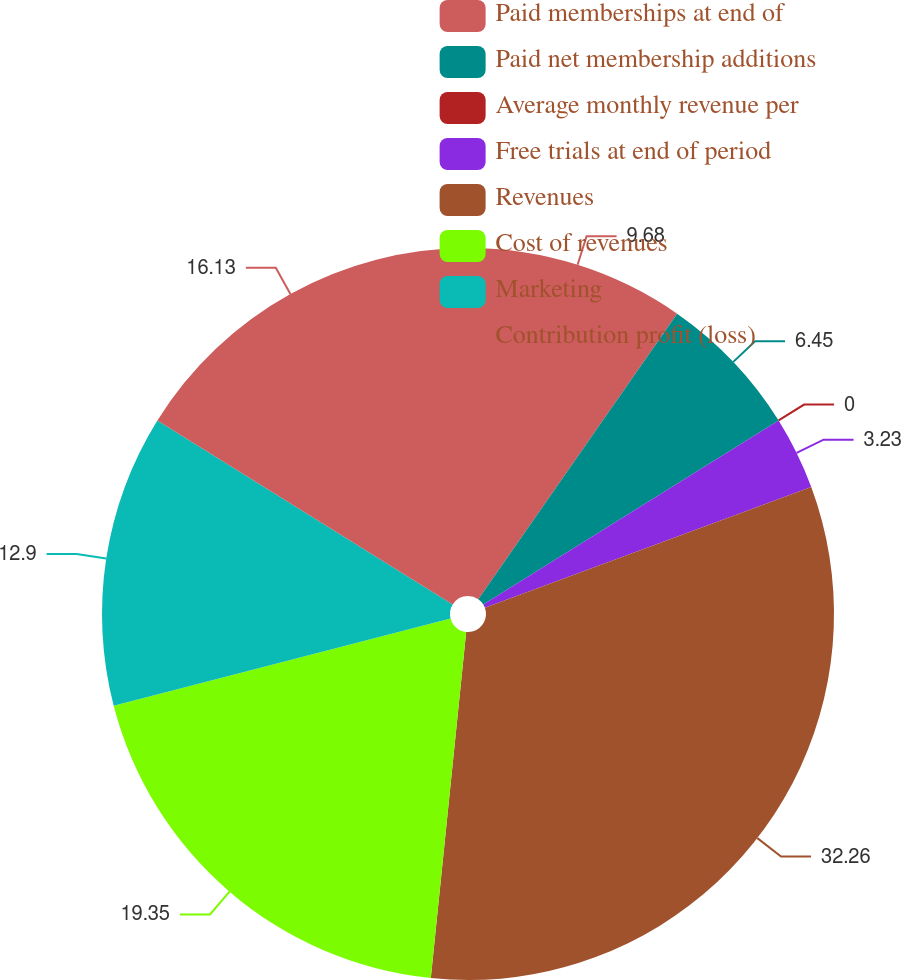Convert chart. <chart><loc_0><loc_0><loc_500><loc_500><pie_chart><fcel>Paid memberships at end of<fcel>Paid net membership additions<fcel>Average monthly revenue per<fcel>Free trials at end of period<fcel>Revenues<fcel>Cost of revenues<fcel>Marketing<fcel>Contribution profit (loss)<nl><fcel>9.68%<fcel>6.45%<fcel>0.0%<fcel>3.23%<fcel>32.26%<fcel>19.35%<fcel>12.9%<fcel>16.13%<nl></chart> 